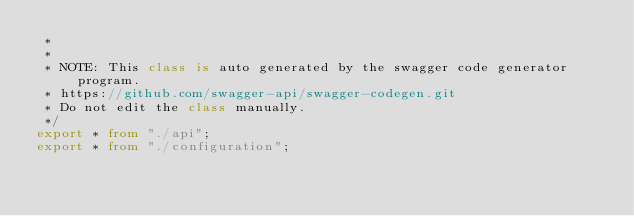<code> <loc_0><loc_0><loc_500><loc_500><_TypeScript_> * 
 *
 * NOTE: This class is auto generated by the swagger code generator program.
 * https://github.com/swagger-api/swagger-codegen.git
 * Do not edit the class manually.
 */
export * from "./api";
export * from "./configuration";

</code> 